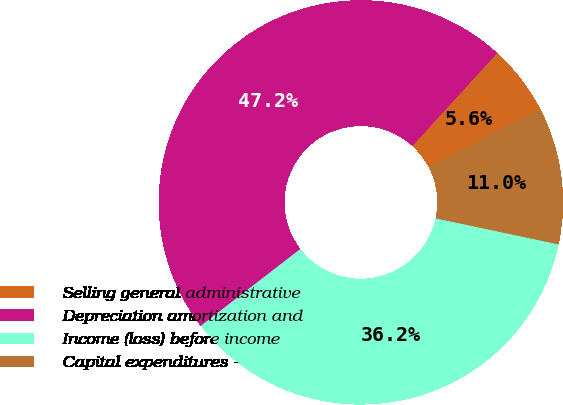Convert chart. <chart><loc_0><loc_0><loc_500><loc_500><pie_chart><fcel>Selling general administrative<fcel>Depreciation amortization and<fcel>Income (loss) before income<fcel>Capital expenditures -<nl><fcel>5.57%<fcel>47.23%<fcel>36.21%<fcel>10.99%<nl></chart> 